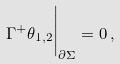Convert formula to latex. <formula><loc_0><loc_0><loc_500><loc_500>\Gamma ^ { + } \theta _ { 1 , 2 } \Big | _ { \partial \Sigma } = 0 \, ,</formula> 